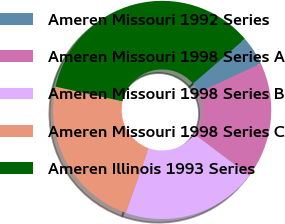<chart> <loc_0><loc_0><loc_500><loc_500><pie_chart><fcel>Ameren Missouri 1992 Series<fcel>Ameren Missouri 1998 Series A<fcel>Ameren Missouri 1998 Series B<fcel>Ameren Missouri 1998 Series C<fcel>Ameren Illinois 1993 Series<nl><fcel>4.32%<fcel>17.27%<fcel>20.14%<fcel>23.02%<fcel>35.25%<nl></chart> 